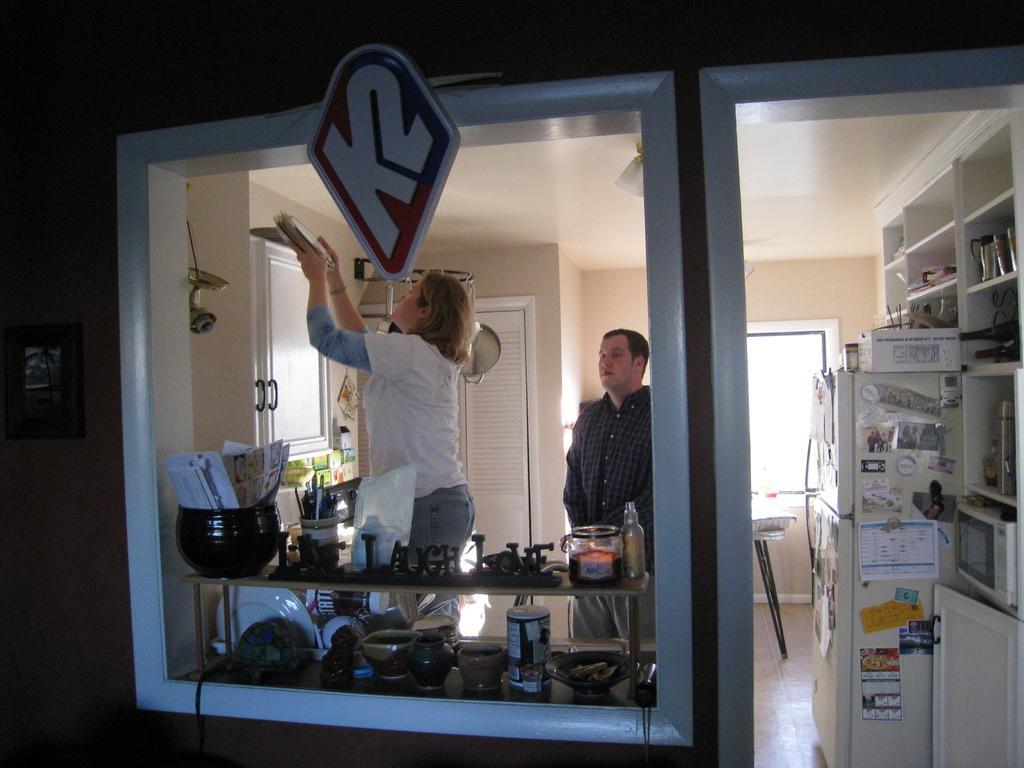Please provide a concise description of this image. In this image I can see in the middle there is a glass and a woman is in the white color dress, she is adjusting the plates. It looks like a kitchen room, in the middle a man is standing, he wore shirt and short. On the right side there is a fridge and a glass window. 